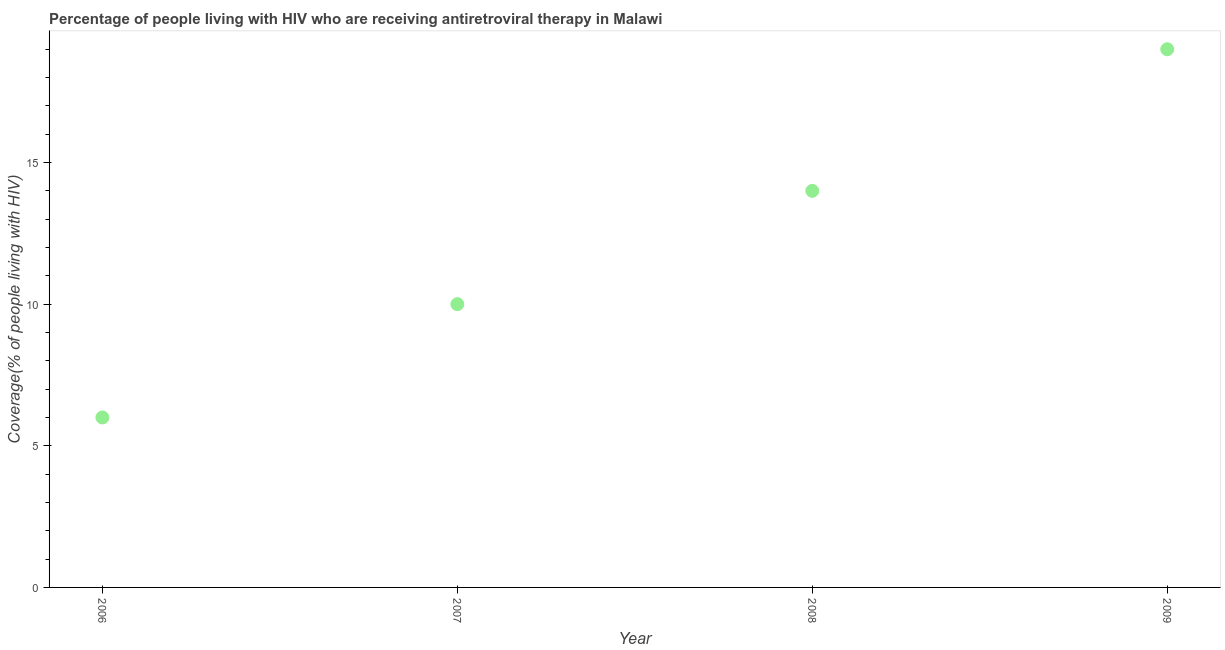What is the antiretroviral therapy coverage in 2007?
Provide a succinct answer. 10. Across all years, what is the maximum antiretroviral therapy coverage?
Give a very brief answer. 19. Across all years, what is the minimum antiretroviral therapy coverage?
Offer a terse response. 6. What is the sum of the antiretroviral therapy coverage?
Keep it short and to the point. 49. What is the difference between the antiretroviral therapy coverage in 2007 and 2009?
Your answer should be very brief. -9. What is the average antiretroviral therapy coverage per year?
Your answer should be very brief. 12.25. What is the ratio of the antiretroviral therapy coverage in 2007 to that in 2008?
Provide a succinct answer. 0.71. What is the difference between the highest and the second highest antiretroviral therapy coverage?
Give a very brief answer. 5. Is the sum of the antiretroviral therapy coverage in 2007 and 2009 greater than the maximum antiretroviral therapy coverage across all years?
Provide a succinct answer. Yes. What is the difference between the highest and the lowest antiretroviral therapy coverage?
Make the answer very short. 13. In how many years, is the antiretroviral therapy coverage greater than the average antiretroviral therapy coverage taken over all years?
Give a very brief answer. 2. Does the antiretroviral therapy coverage monotonically increase over the years?
Keep it short and to the point. Yes. How many dotlines are there?
Keep it short and to the point. 1. What is the difference between two consecutive major ticks on the Y-axis?
Your answer should be very brief. 5. Are the values on the major ticks of Y-axis written in scientific E-notation?
Make the answer very short. No. What is the title of the graph?
Offer a terse response. Percentage of people living with HIV who are receiving antiretroviral therapy in Malawi. What is the label or title of the X-axis?
Give a very brief answer. Year. What is the label or title of the Y-axis?
Ensure brevity in your answer.  Coverage(% of people living with HIV). What is the Coverage(% of people living with HIV) in 2007?
Offer a terse response. 10. What is the Coverage(% of people living with HIV) in 2009?
Offer a very short reply. 19. What is the difference between the Coverage(% of people living with HIV) in 2006 and 2007?
Your answer should be compact. -4. What is the difference between the Coverage(% of people living with HIV) in 2006 and 2009?
Your answer should be compact. -13. What is the difference between the Coverage(% of people living with HIV) in 2007 and 2009?
Ensure brevity in your answer.  -9. What is the ratio of the Coverage(% of people living with HIV) in 2006 to that in 2008?
Give a very brief answer. 0.43. What is the ratio of the Coverage(% of people living with HIV) in 2006 to that in 2009?
Provide a short and direct response. 0.32. What is the ratio of the Coverage(% of people living with HIV) in 2007 to that in 2008?
Provide a succinct answer. 0.71. What is the ratio of the Coverage(% of people living with HIV) in 2007 to that in 2009?
Provide a succinct answer. 0.53. What is the ratio of the Coverage(% of people living with HIV) in 2008 to that in 2009?
Give a very brief answer. 0.74. 